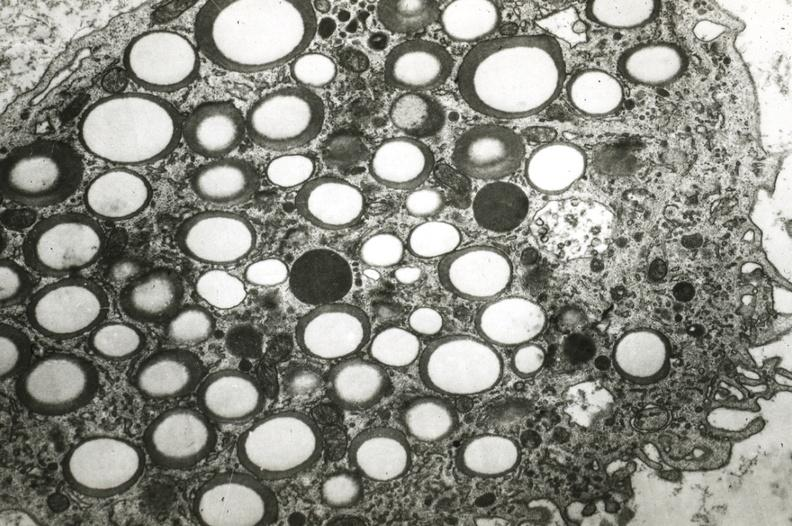where is this?
Answer the question using a single word or phrase. Vasculature 